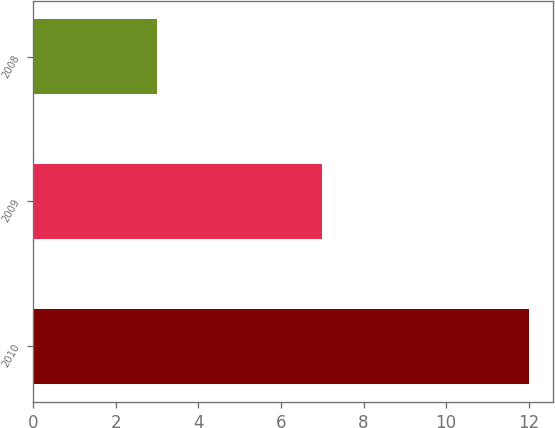Convert chart. <chart><loc_0><loc_0><loc_500><loc_500><bar_chart><fcel>2010<fcel>2009<fcel>2008<nl><fcel>12<fcel>7<fcel>3<nl></chart> 